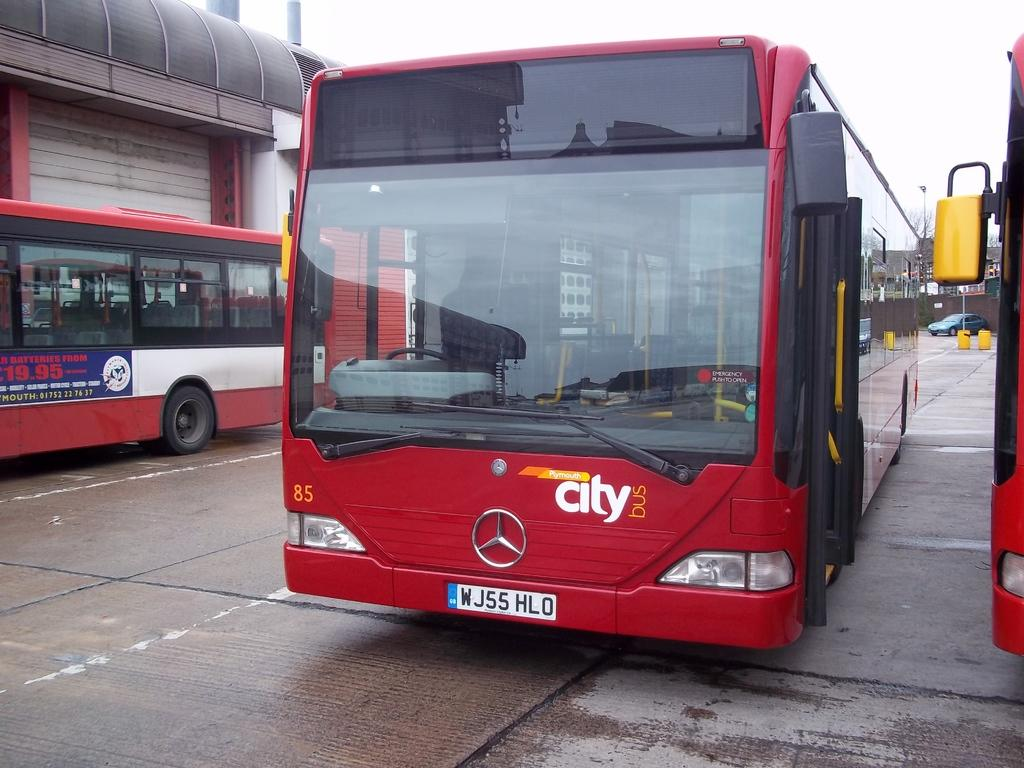<image>
Render a clear and concise summary of the photo. A city bus is parked without any indication of it's route showing. 